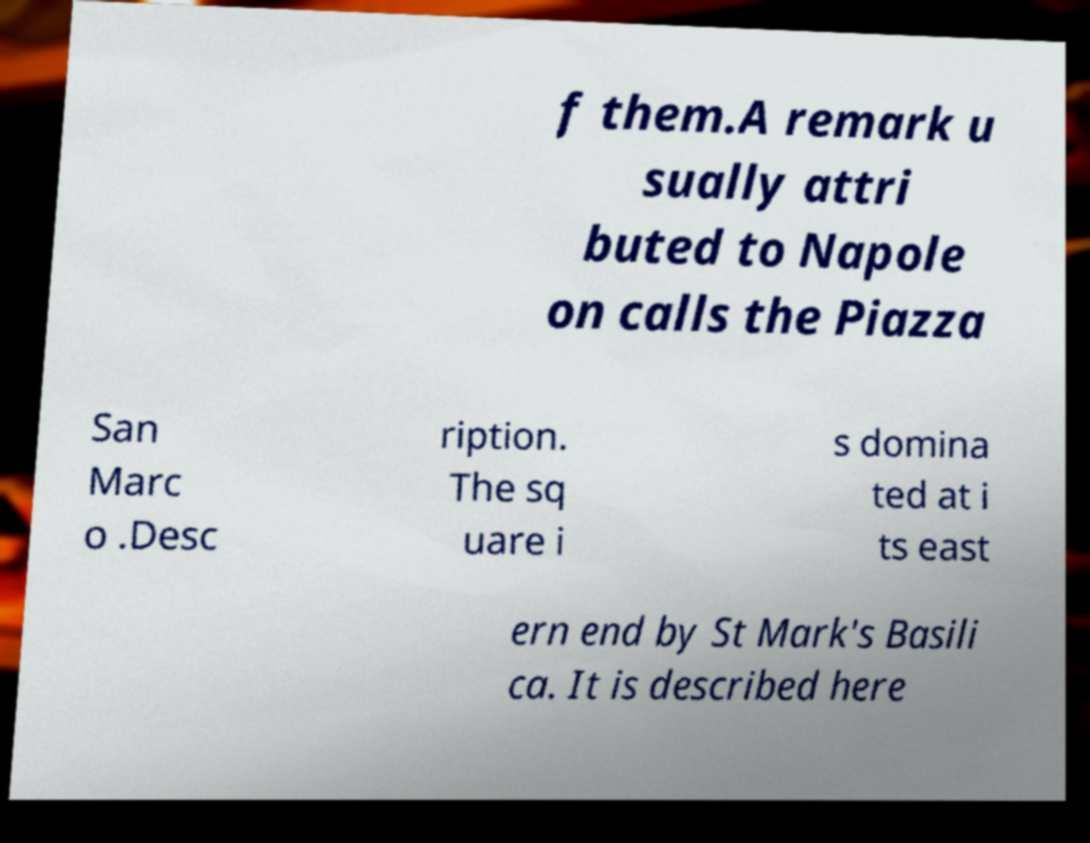Please read and relay the text visible in this image. What does it say? f them.A remark u sually attri buted to Napole on calls the Piazza San Marc o .Desc ription. The sq uare i s domina ted at i ts east ern end by St Mark's Basili ca. It is described here 